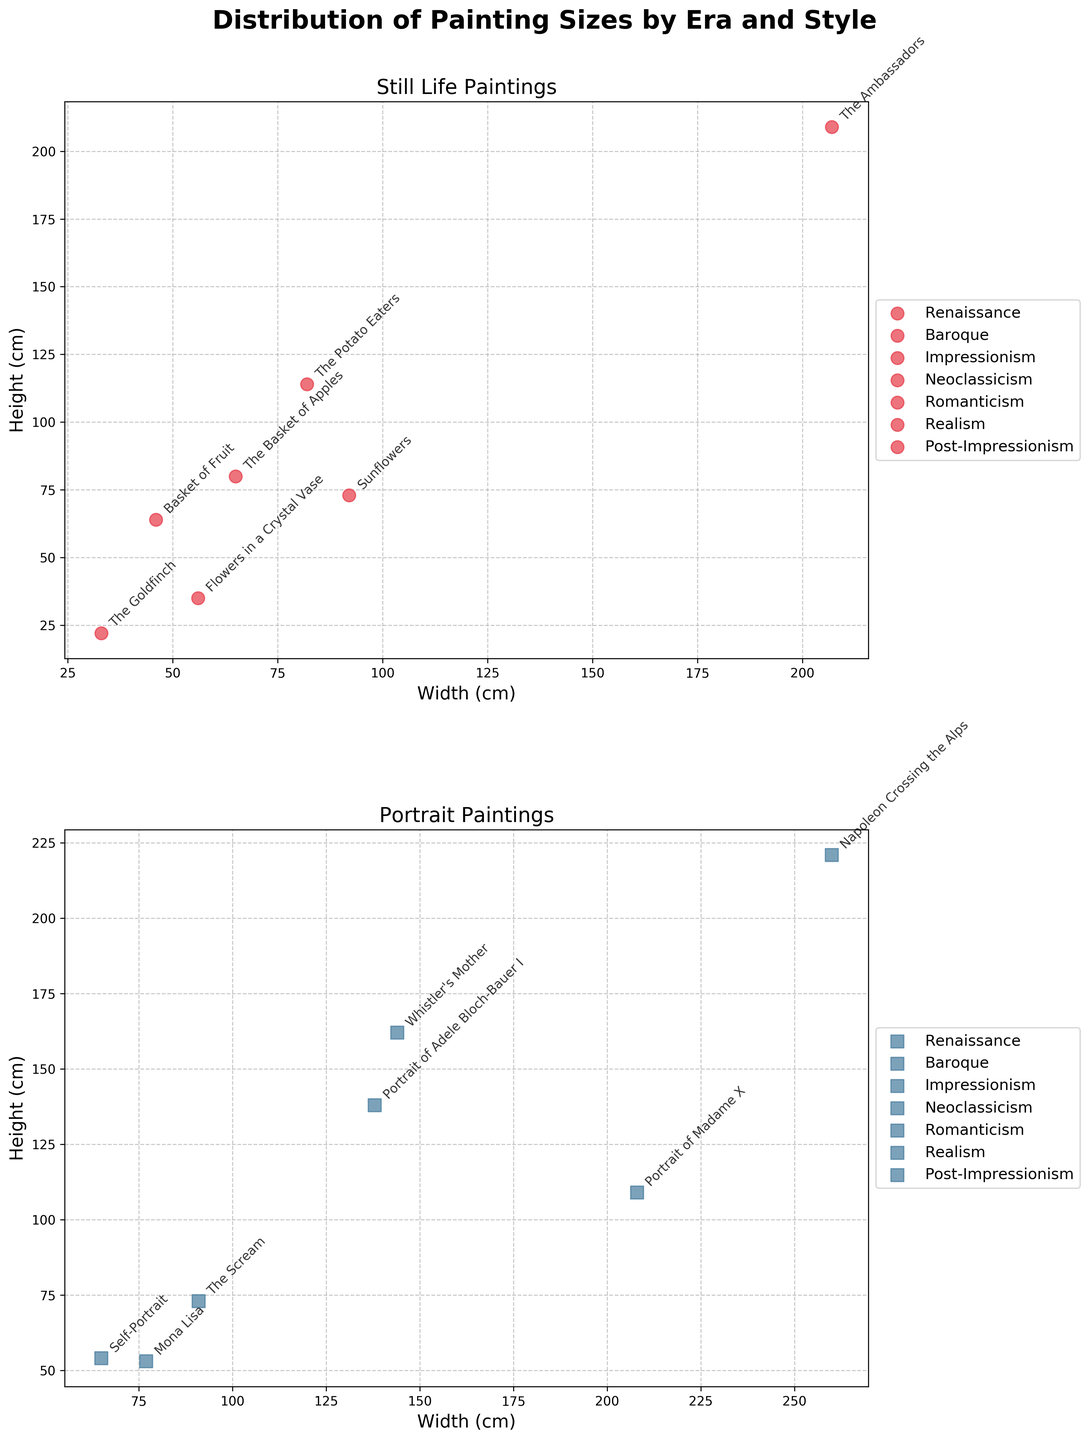what is the title of the plot? The title is shown at the top of the figure, describing the distribution of painting sizes.
Answer: Distribution of Painting Sizes by Era and Style How many data points are in the "Portrait" scatter plot? Count the number of paintings labeled on the "Portrait" subplot to find the number of data points.
Answer: 7 Which era has the painting with the largest height in the "Still Life" scatter plot? Find the point with the highest y-value (height) in the "Still Life" subplot and identify its era from the label.
Answer: Baroque Between "Still Life" and "Portrait" styles, which has the painting with the smallest width? Compare the smallest x-values (width) in both "Still Life" and "Portrait" subplots to determine which style has the smaller width.
Answer: Realism (The Goldfinch by Carel Fabritius) What is the approximate width and height of "The Ambassadors by Hans Holbein the Younger"? Locate the label "The Ambassadors" in the "Still Life" subplot and read the corresponding x (width) and y (height) values.
Answer: Approximately 207 cm width and 209 cm height Which style has more variety in painting sizes in the Renaissance era: "Still Life" or "Portrait"? Compare the range of width and height of Renaissance-era paintings in both scatter plots ("Still Life" and "Portrait").
Answer: Portrait Which painting in the "Portrait" scatter plot has the closest width to "Mona Lisa" but a larger height? Find "Mona Lisa" in the "Portrait" subplot, then locate the nearest point with a larger y-value (height).
Answer: Portrait of Madame X 1. Find the point with the maximum height (y-value) in the "Portrait" subplot.
 2. Get the width (x-value) and height (y-value) of that point.
 3. Calculate the ratio height/width. The ratio for "Napoleon Crossing the Alps by Jacques-Louis David" with height of 221 cm and width of 260 cm is 221/260.
Answer: Approximately 0.85 